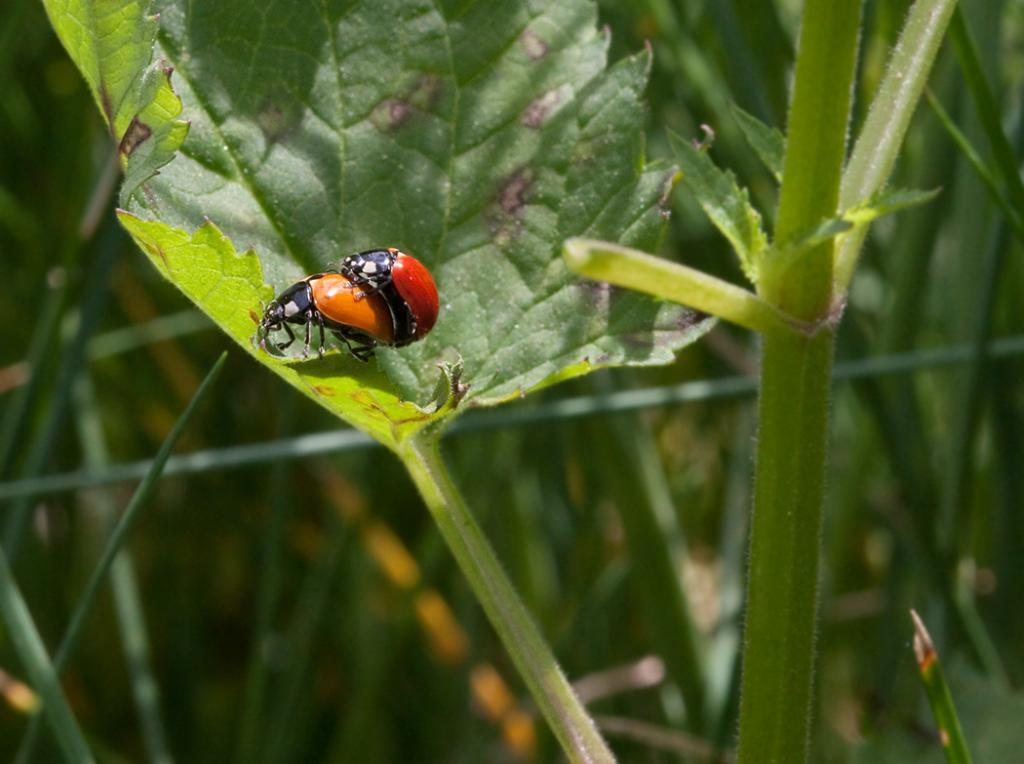What is the main subject of the picture? The main subject of the picture is an insect. Where is the insect located in the picture? The insect is sitting on a leaf in the picture. What is the insect sitting on? The insect is sitting on a leaf. What can be seen in the background of the picture? There are plants in the background of the picture. What type of pen is the insect using to write on the leaf? There is no pen present in the image, and the insect is not writing on the leaf. 